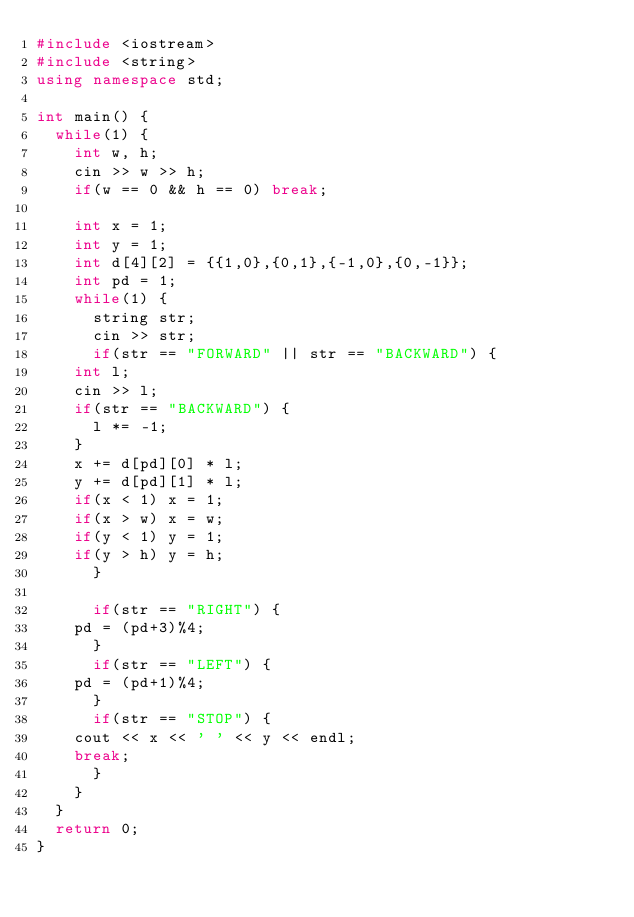<code> <loc_0><loc_0><loc_500><loc_500><_C++_>#include <iostream>
#include <string>
using namespace std;

int main() {
  while(1) {
    int w, h;
    cin >> w >> h;
    if(w == 0 && h == 0) break;

    int x = 1;
    int y = 1;
    int d[4][2] = {{1,0},{0,1},{-1,0},{0,-1}};
    int pd = 1;
    while(1) {
      string str;
      cin >> str;
      if(str == "FORWARD" || str == "BACKWARD") {
	int l;
	cin >> l;
	if(str == "BACKWARD") {
	  l *= -1;
	}
	x += d[pd][0] * l;
	y += d[pd][1] * l;
	if(x < 1) x = 1;
	if(x > w) x = w;
	if(y < 1) y = 1;
	if(y > h) y = h;
      }

      if(str == "RIGHT") {
	pd = (pd+3)%4;
      }
      if(str == "LEFT") {
	pd = (pd+1)%4;
      }
      if(str == "STOP") {
	cout << x << ' ' << y << endl;
	break;
      }
    }
  }
  return 0;
}</code> 